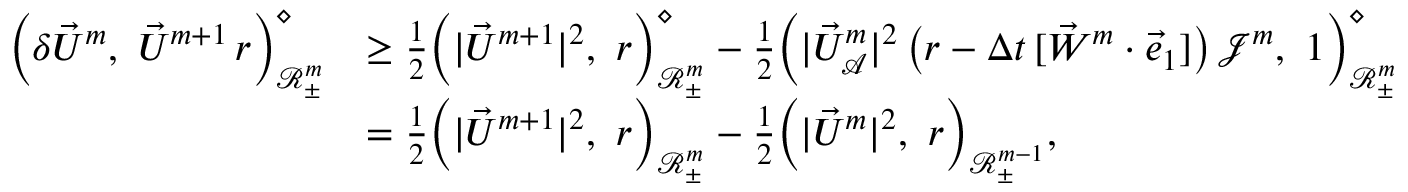<formula> <loc_0><loc_0><loc_500><loc_500>\begin{array} { r l } { \left ( \delta \vec { U } ^ { m } , \vec { U } ^ { m + 1 } \, r \right ) _ { \ m a t h s c r { R } _ { \pm } ^ { m } } ^ { \diamond } } & { \geq \frac { 1 } { 2 } \left ( | \vec { U } ^ { m + 1 } | ^ { 2 } , r \right ) _ { \ m a t h s c r { R } _ { \pm } ^ { m } } ^ { \diamond } - \frac { 1 } { 2 } \left ( | \vec { U } _ { \mathcal { A } } ^ { m } | ^ { 2 } \, \left ( r - \Delta t \, [ \vec { W } ^ { m } \cdot \vec { e } _ { 1 } ] \right ) \, \mathcal { J } ^ { m } , 1 \right ) _ { \ m a t h s c r { R } _ { \pm } ^ { m } } ^ { \diamond } } \\ & { = \frac { 1 } { 2 } \left ( | \vec { U } ^ { m + 1 } | ^ { 2 } , r \right ) _ { \ m a t h s c r { R } _ { \pm } ^ { m } } - \frac { 1 } { 2 } \left ( | \vec { U } ^ { m } | ^ { 2 } , r \right ) _ { \ m a t h s c r { R } _ { \pm } ^ { m - 1 } } , } \end{array}</formula> 